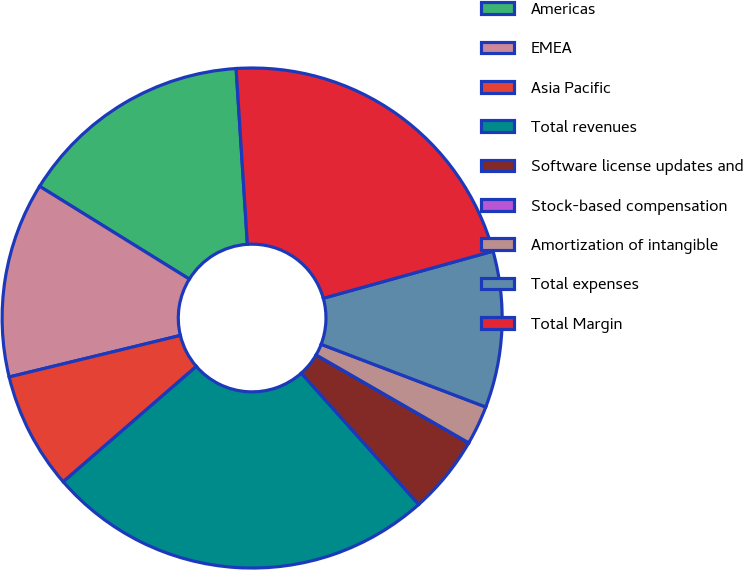Convert chart to OTSL. <chart><loc_0><loc_0><loc_500><loc_500><pie_chart><fcel>Americas<fcel>EMEA<fcel>Asia Pacific<fcel>Total revenues<fcel>Software license updates and<fcel>Stock-based compensation<fcel>Amortization of intangible<fcel>Total expenses<fcel>Total Margin<nl><fcel>15.15%<fcel>12.62%<fcel>7.58%<fcel>25.24%<fcel>5.06%<fcel>0.01%<fcel>2.53%<fcel>10.1%<fcel>21.71%<nl></chart> 